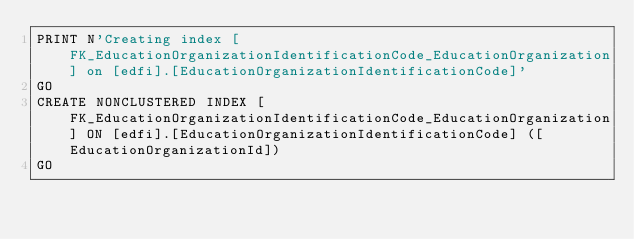<code> <loc_0><loc_0><loc_500><loc_500><_SQL_>PRINT N'Creating index [FK_EducationOrganizationIdentificationCode_EducationOrganization] on [edfi].[EducationOrganizationIdentificationCode]'
GO
CREATE NONCLUSTERED INDEX [FK_EducationOrganizationIdentificationCode_EducationOrganization] ON [edfi].[EducationOrganizationIdentificationCode] ([EducationOrganizationId])
GO
</code> 